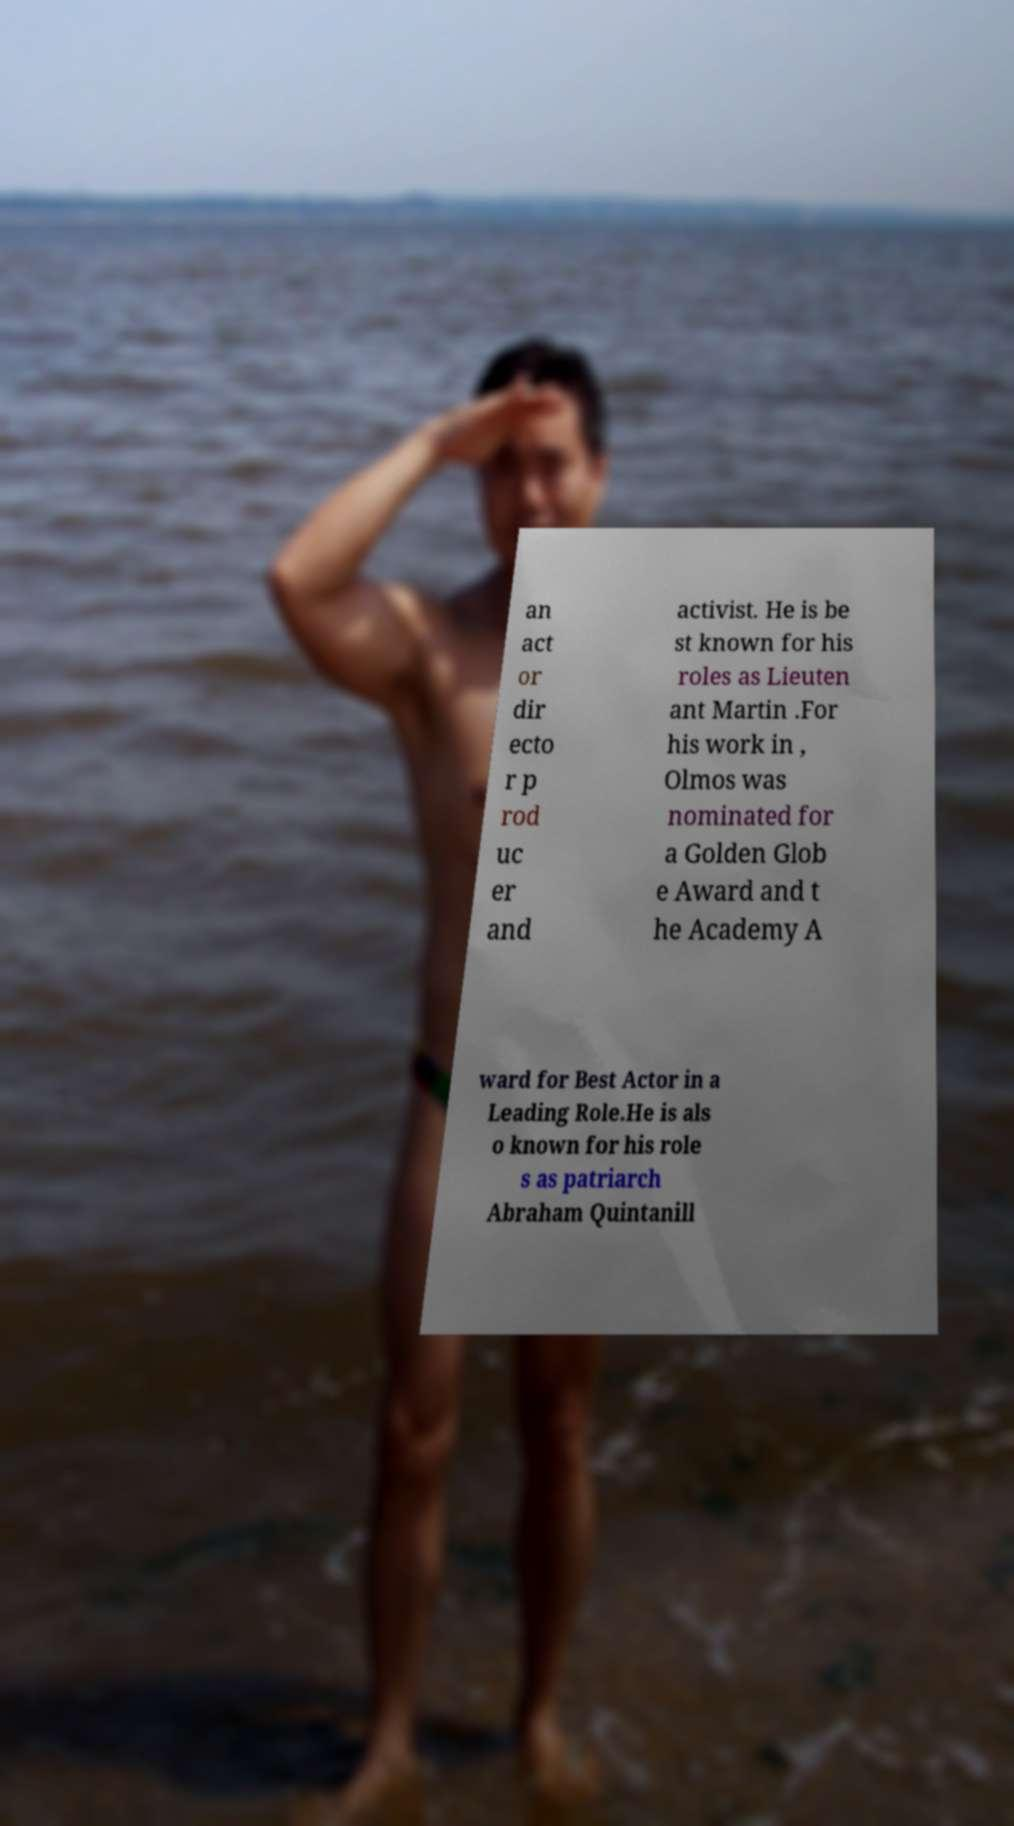Can you read and provide the text displayed in the image?This photo seems to have some interesting text. Can you extract and type it out for me? an act or dir ecto r p rod uc er and activist. He is be st known for his roles as Lieuten ant Martin .For his work in , Olmos was nominated for a Golden Glob e Award and t he Academy A ward for Best Actor in a Leading Role.He is als o known for his role s as patriarch Abraham Quintanill 